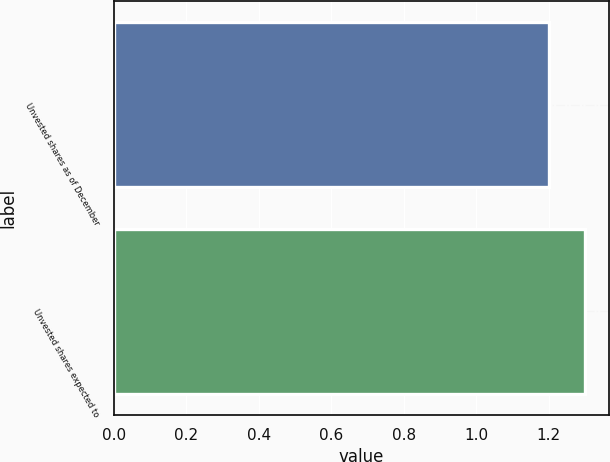Convert chart. <chart><loc_0><loc_0><loc_500><loc_500><bar_chart><fcel>Unvested shares as of December<fcel>Unvested shares expected to<nl><fcel>1.2<fcel>1.3<nl></chart> 